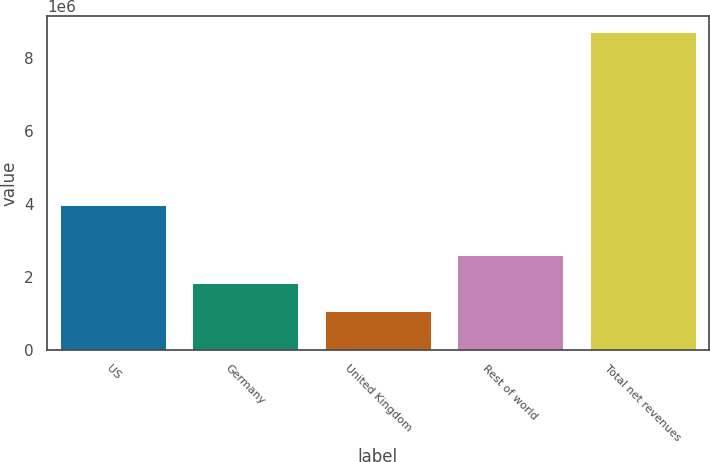Convert chart to OTSL. <chart><loc_0><loc_0><loc_500><loc_500><bar_chart><fcel>US<fcel>Germany<fcel>United Kingdom<fcel>Rest of world<fcel>Total net revenues<nl><fcel>3.98507e+06<fcel>1.82199e+06<fcel>1.05473e+06<fcel>2.58926e+06<fcel>8.72736e+06<nl></chart> 